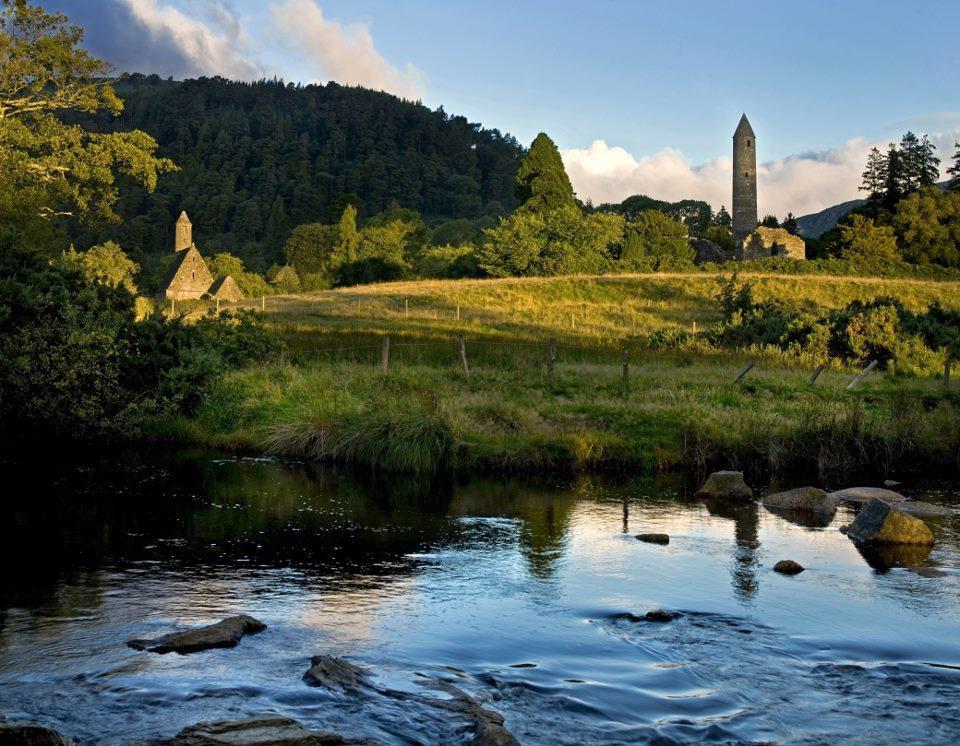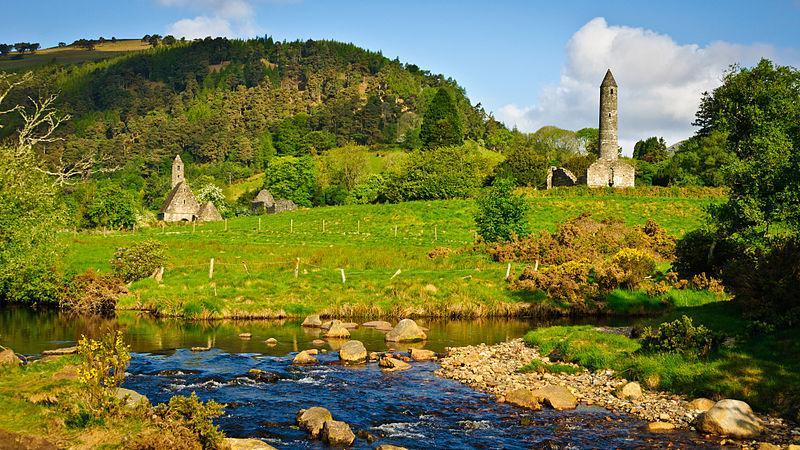The first image is the image on the left, the second image is the image on the right. Evaluate the accuracy of this statement regarding the images: "An image shows an old gray building featuring a cone-topped tower in the foreground, with no water or bridge visible.". Is it true? Answer yes or no. No. 